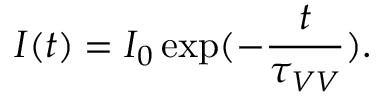Convert formula to latex. <formula><loc_0><loc_0><loc_500><loc_500>I ( t ) = I _ { 0 } \exp ( - \frac { t } { \tau _ { V V } } ) .</formula> 